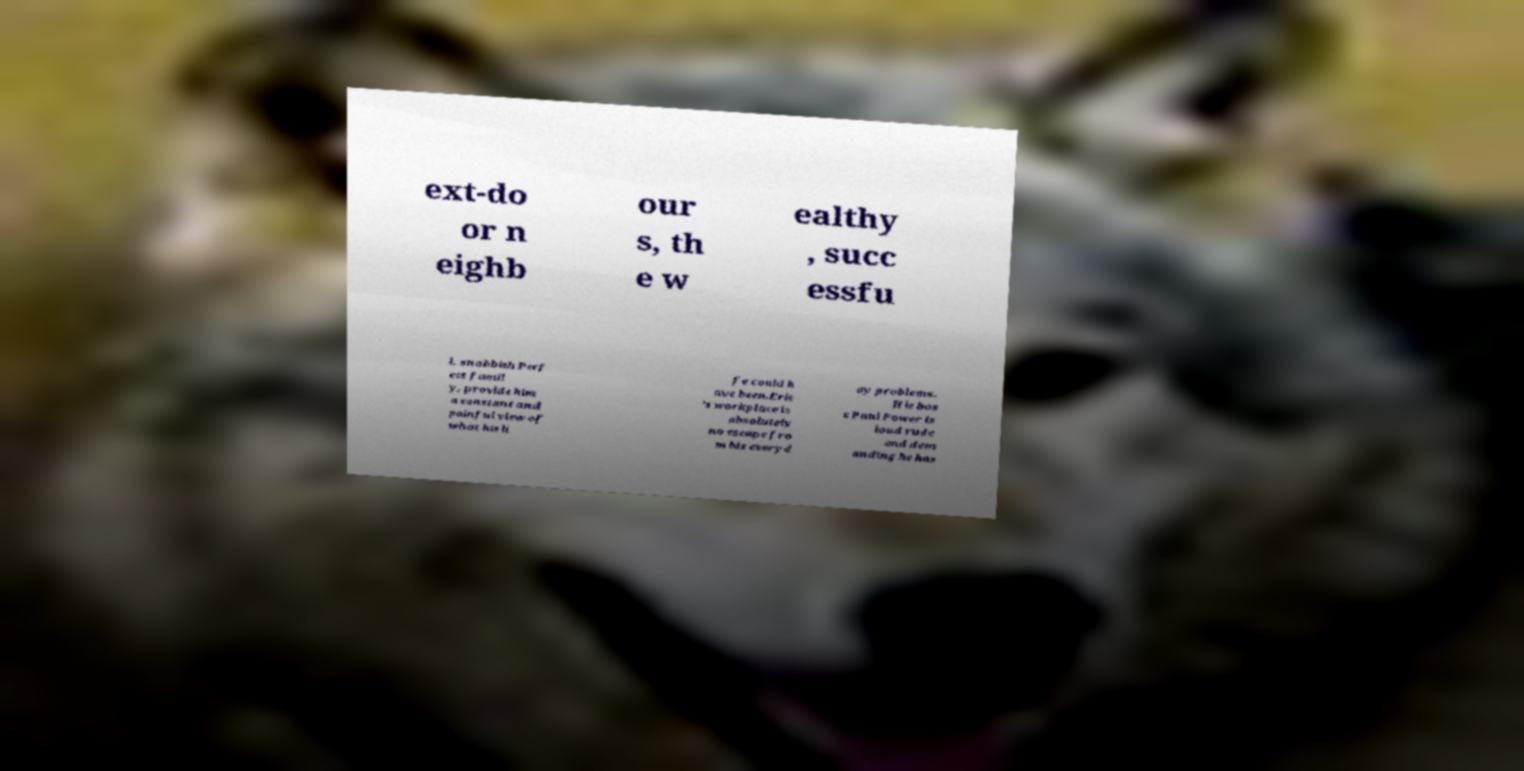Could you extract and type out the text from this image? ext-do or n eighb our s, th e w ealthy , succ essfu l, snobbish Perf ect famil y, provide him a constant and painful view of what his li fe could h ave been.Eric 's workplace is absolutely no escape fro m his everyd ay problems. His bos s Paul Power is loud rude and dem anding he has 